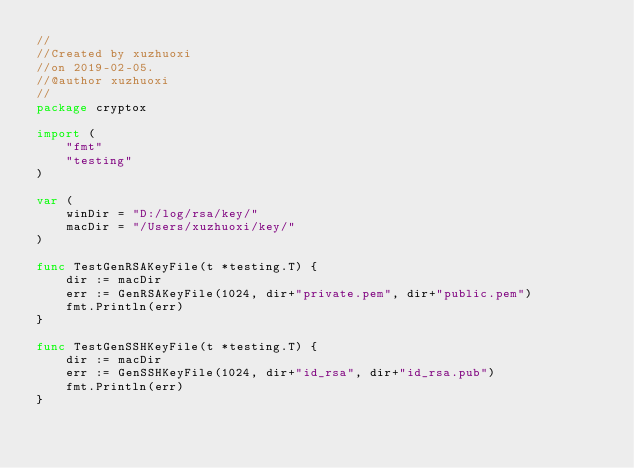Convert code to text. <code><loc_0><loc_0><loc_500><loc_500><_Go_>//
//Created by xuzhuoxi
//on 2019-02-05.
//@author xuzhuoxi
//
package cryptox

import (
	"fmt"
	"testing"
)

var (
	winDir = "D:/log/rsa/key/"
	macDir = "/Users/xuzhuoxi/key/"
)

func TestGenRSAKeyFile(t *testing.T) {
	dir := macDir
	err := GenRSAKeyFile(1024, dir+"private.pem", dir+"public.pem")
	fmt.Println(err)
}

func TestGenSSHKeyFile(t *testing.T) {
	dir := macDir
	err := GenSSHKeyFile(1024, dir+"id_rsa", dir+"id_rsa.pub")
	fmt.Println(err)
}
</code> 